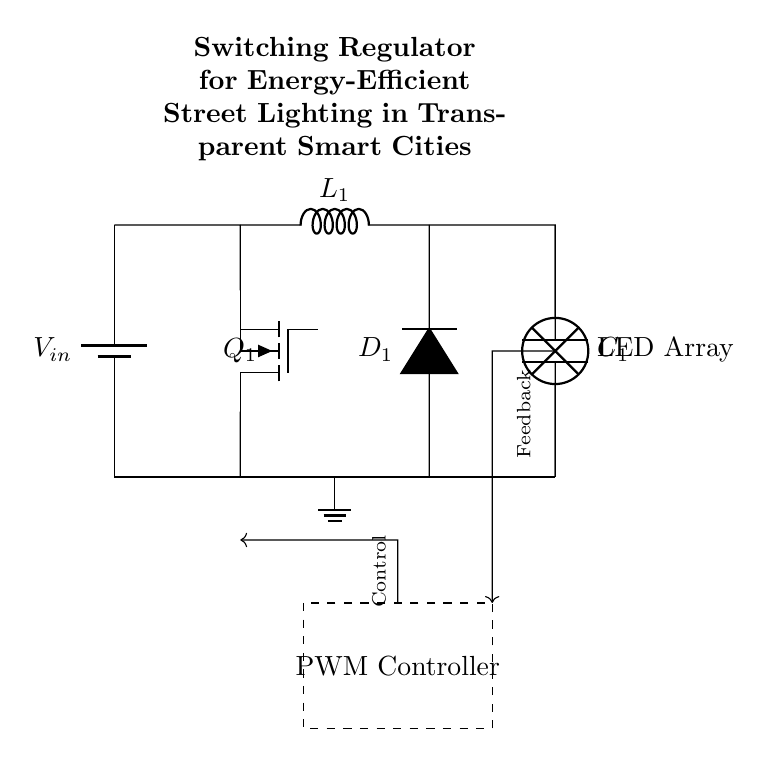What is the input voltage of the circuit? The input voltage is denoted as \( V_{in} \) next to the battery component, which serves as the power source for the circuit.
Answer: V_in What type of control mechanism is used in this circuit? The circuit features a PWM (Pulse Width Modulation) controller, indicated by the dashed rectangle labeled "PWM Controller." This controller modifies the duty cycle of the switching signal based on feedback to regulate output.
Answer: PWM Controller What is the function of the component labeled \( Q_1 \)? The component labeled \( Q_1 \) is a transistor (specifically, a MOSFET), which acts as a switch in the circuit to control the current flow based on the control signal from the PWM controller.
Answer: Switch What is the purpose of the inductor labeled \( L_1 \)? The inductor \( L_1 \) stores energy when the MOSFET is on and releases it when the MOSFET is off, smoothing out the output current and helping with the energy efficiency of the street lighting.
Answer: Energy storage How does the feedback mechanism work in this circuit? The feedback mechanism is represented by the arrow pointing from the output (LED array) back to the PWM controller. This feedback helps adjust the control signal based on the output, ensuring that the desired brightness of the LED array is maintained.
Answer: Stability control What happens to the current when the MOSFET \( Q_1 \) is turned on? When the MOSFET \( Q_1 \) is turned on, it creates a low-resistance path for current to flow from the input through the inductor \( L_1 \), charging it and increasing the output voltage supplied to the LED array.
Answer: Current flows through How many capacitors are present in the circuit? There is one capacitor labeled \( C_1 \) in the circuit diagram, placed after the inductor to filter the output voltage provided to the LED load.
Answer: One 